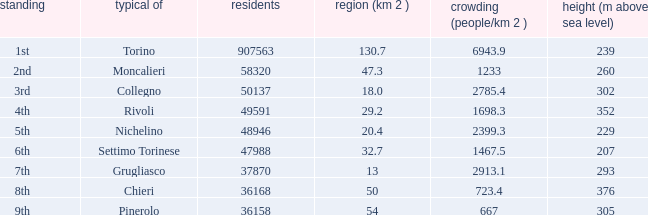How many heights does the common with an area of 13 1.0. 